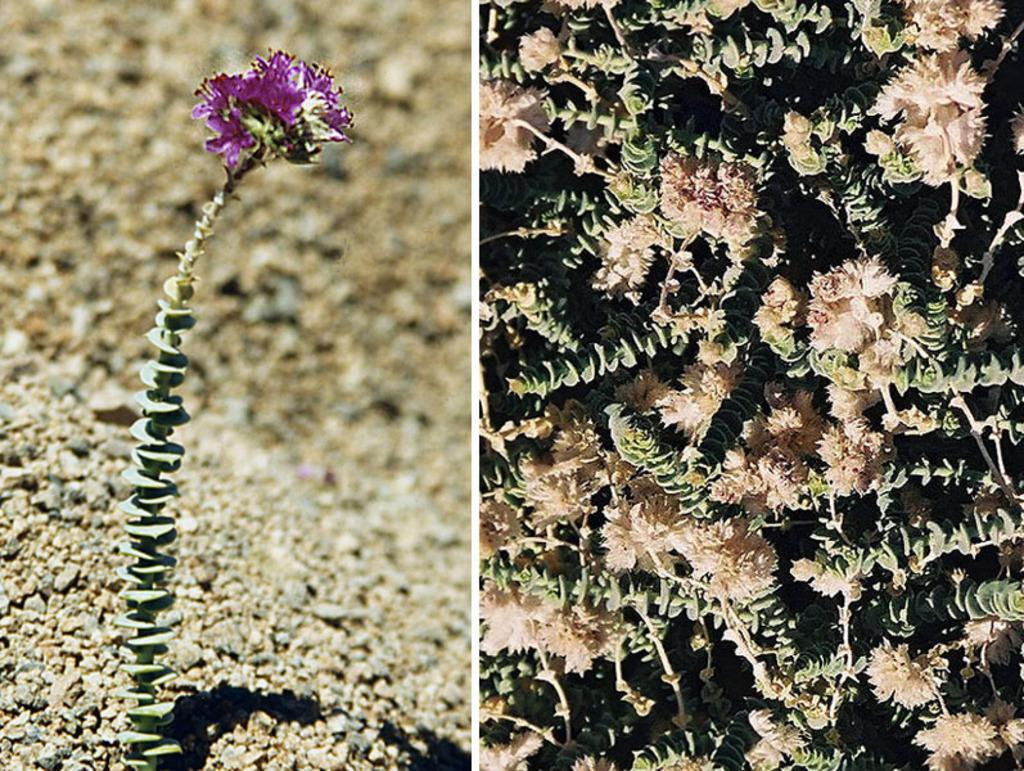What type of flower is present on the plant in the first image? The plant in the first image has a violet flower. How many different types of flowers are shown in the images? There are two types of flowers shown in the images: violet flowers in the first image and cream-colored flowers in the second image. Can you see the ocean in the background of the images? There is no ocean visible in the background of the images; they only show plants with flowers. 